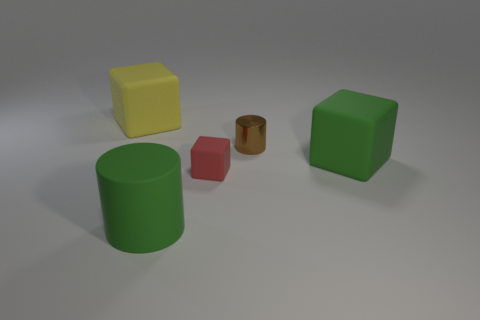Is there any other thing that is made of the same material as the tiny cylinder?
Your response must be concise. No. Is the size of the metallic cylinder that is to the right of the matte cylinder the same as the red rubber object that is left of the brown cylinder?
Offer a terse response. Yes. How many other objects are there of the same size as the matte cylinder?
Provide a succinct answer. 2. There is a cylinder that is behind the green object in front of the big green rubber object that is right of the small brown metal thing; what is its material?
Offer a terse response. Metal. Does the yellow matte block have the same size as the green object that is left of the small metal thing?
Keep it short and to the point. Yes. How big is the thing that is both on the right side of the tiny matte object and behind the green matte cube?
Ensure brevity in your answer.  Small. Is there a cube that has the same color as the big matte cylinder?
Your response must be concise. Yes. There is a tiny block in front of the green thing behind the rubber cylinder; what color is it?
Make the answer very short. Red. Are there fewer yellow cubes in front of the red block than tiny red rubber things that are to the right of the tiny brown shiny cylinder?
Ensure brevity in your answer.  No. Is the size of the yellow cube the same as the green rubber cube?
Provide a succinct answer. Yes. 